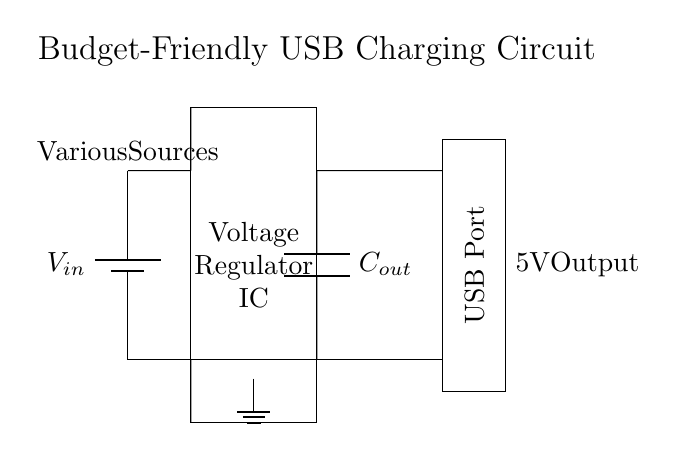What does the rectangle labeled "Voltage Regulator IC" represent? The rectangle labeled "Voltage Regulator IC" represents the voltage regulation component that maintains a steady output voltage. This is crucial when charging devices via USB as it ensures the output remains consistent at 5V.
Answer: Voltage Regulator IC What is the output voltage from this circuit? The output voltage is indicated as 5V, marked next to the USB Port label on the right side of the circuit diagram. This means the regulator is designed to output this specific voltage.
Answer: 5V How many capacitors are present in the circuit? There is one capacitor shown, labeled as "Cout." Capacitors are often included in circuits to stabilize the voltage output and filter noise, particularly at the output stage.
Answer: 1 What type of device connects to the USB port? The USB port is used to connect devices that require charging, such as smartphones, tablets, or other USB-powered gadgets. The rectangle indicates this is a standard USB charging output.
Answer: USB-powered devices What is the function of the ground in this circuit? The ground in the circuit serves as a reference point for the voltage levels. It completes the circuit, allowing current to flow back, and helps to stabilize the voltage levels, ensuring the circuit operates correctly.
Answer: Reference point How is the input voltage sourced in this circuit? The input voltage is sourced from 'Various Sources' as labeled at the top left of the circuit. This indicates that multiple different voltage sources can be connected to the circuit for powering the voltage regulator.
Answer: Various sources 